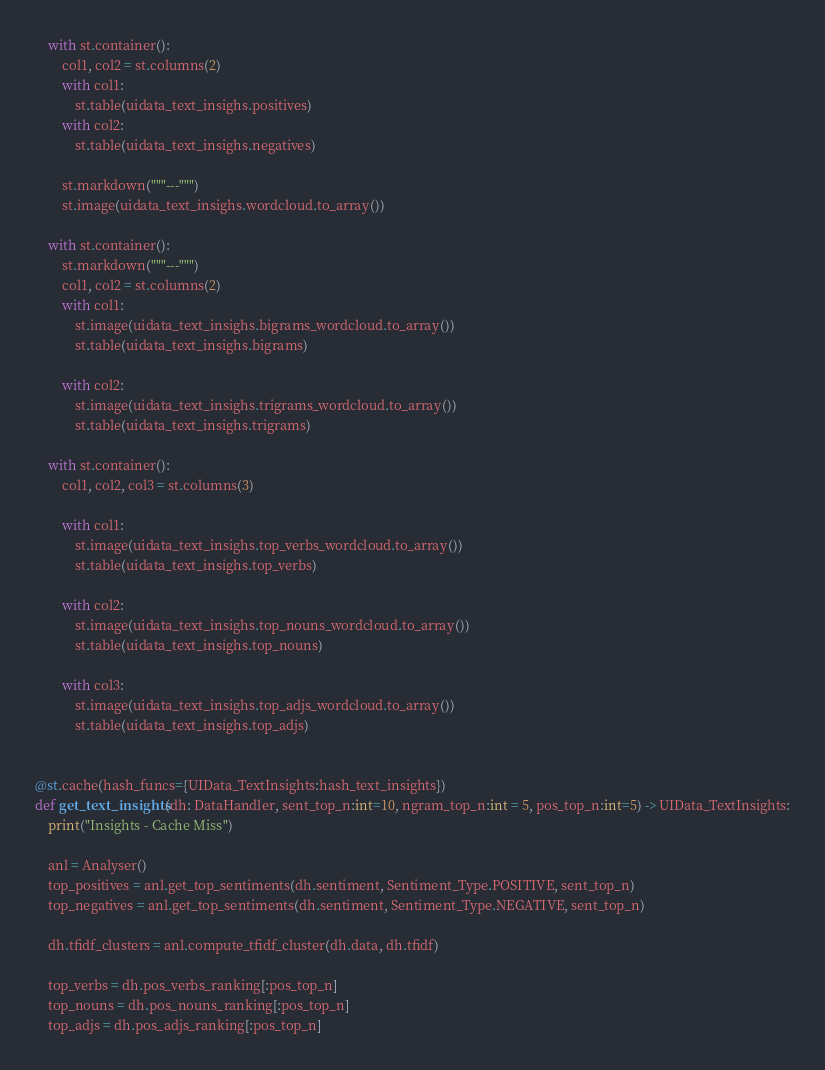<code> <loc_0><loc_0><loc_500><loc_500><_Python_>    with st.container():
        col1, col2 = st.columns(2)
        with col1:
            st.table(uidata_text_insighs.positives)
        with col2:
            st.table(uidata_text_insighs.negatives)

        st.markdown("""---""")
        st.image(uidata_text_insighs.wordcloud.to_array())

    with st.container():
        st.markdown("""---""")
        col1, col2 = st.columns(2)
        with col1:
            st.image(uidata_text_insighs.bigrams_wordcloud.to_array())
            st.table(uidata_text_insighs.bigrams)

        with col2:
            st.image(uidata_text_insighs.trigrams_wordcloud.to_array())
            st.table(uidata_text_insighs.trigrams)

    with st.container():
        col1, col2, col3 = st.columns(3)
        
        with col1:
            st.image(uidata_text_insighs.top_verbs_wordcloud.to_array())
            st.table(uidata_text_insighs.top_verbs)

        with col2:
            st.image(uidata_text_insighs.top_nouns_wordcloud.to_array())
            st.table(uidata_text_insighs.top_nouns)
        
        with col3:
            st.image(uidata_text_insighs.top_adjs_wordcloud.to_array())
            st.table(uidata_text_insighs.top_adjs)


@st.cache(hash_funcs={UIData_TextInsights:hash_text_insights})
def get_text_insights(dh: DataHandler, sent_top_n:int=10, ngram_top_n:int = 5, pos_top_n:int=5) -> UIData_TextInsights:
    print("Insights - Cache Miss")
    
    anl = Analyser()
    top_positives = anl.get_top_sentiments(dh.sentiment, Sentiment_Type.POSITIVE, sent_top_n)
    top_negatives = anl.get_top_sentiments(dh.sentiment, Sentiment_Type.NEGATIVE, sent_top_n)

    dh.tfidf_clusters = anl.compute_tfidf_cluster(dh.data, dh.tfidf)

    top_verbs = dh.pos_verbs_ranking[:pos_top_n]
    top_nouns = dh.pos_nouns_ranking[:pos_top_n]
    top_adjs = dh.pos_adjs_ranking[:pos_top_n]
</code> 